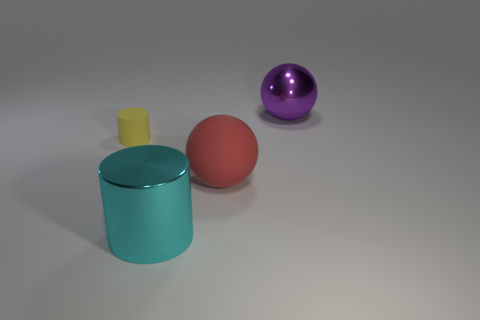Add 4 large brown things. How many objects exist? 8 Add 2 big cyan objects. How many big cyan objects exist? 3 Subtract 0 gray cubes. How many objects are left? 4 Subtract all small matte objects. Subtract all big cyan metallic cylinders. How many objects are left? 2 Add 1 cyan shiny objects. How many cyan shiny objects are left? 2 